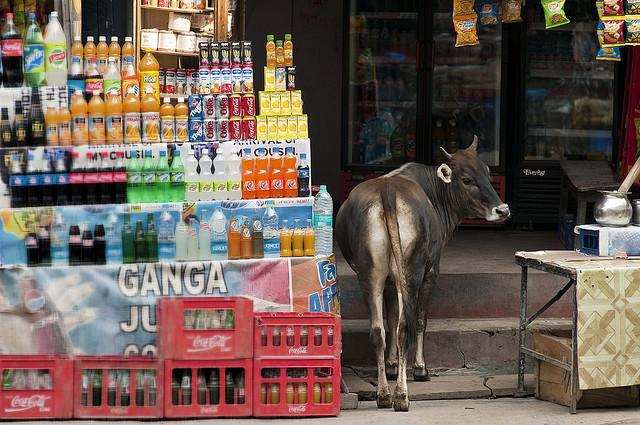The first five letters in white that are on the sign are used in spelling what style? gangnam 